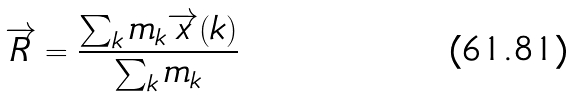<formula> <loc_0><loc_0><loc_500><loc_500>\overrightarrow { R } = \frac { \sum _ { k } m _ { k } \overrightarrow { x } ( k ) } { \sum _ { k } m _ { k } }</formula> 